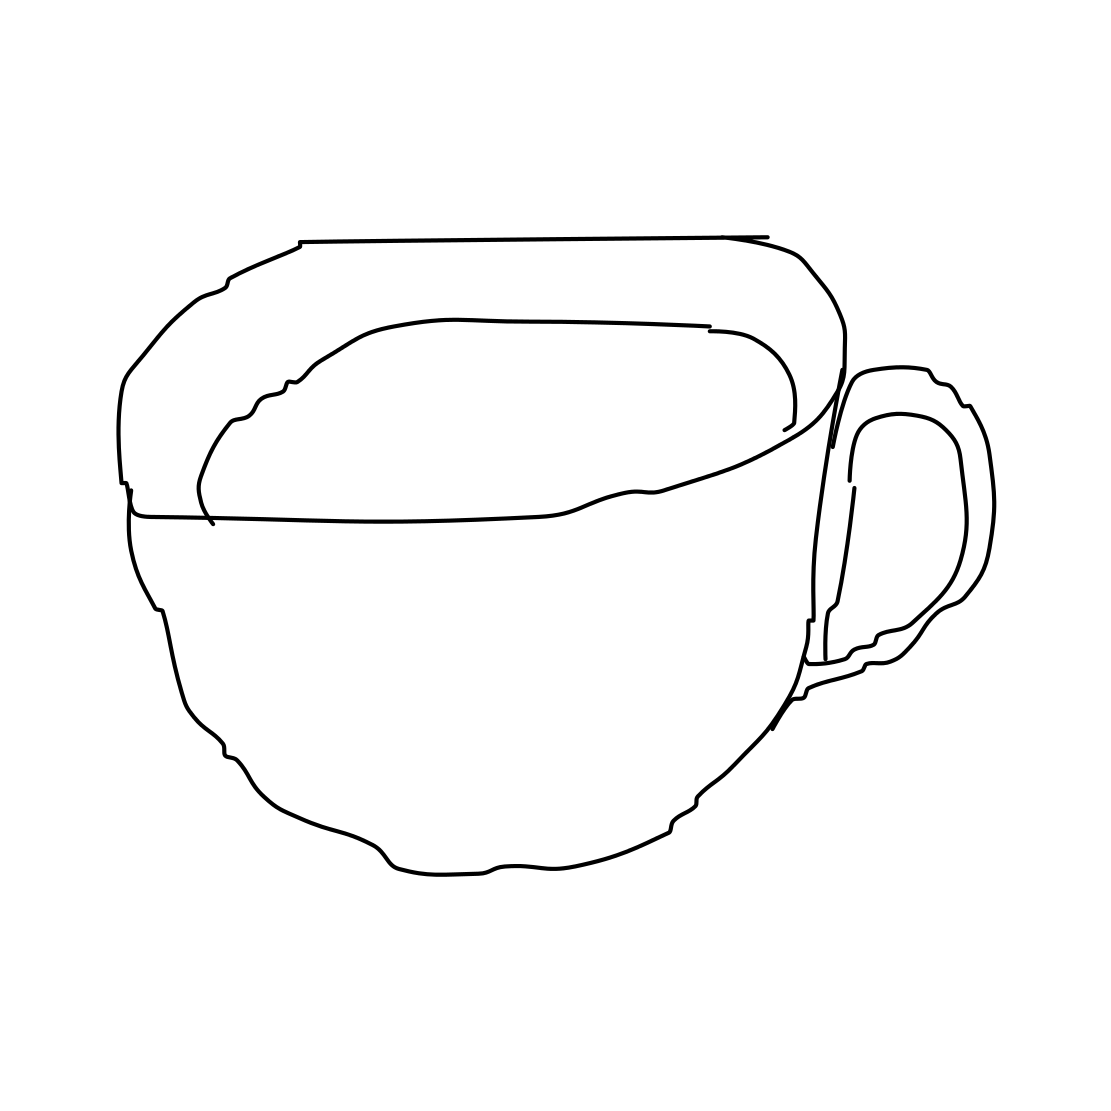Could this image be part of a larger set or collection? It's possible. The minimalist style suggests it could belong to a set that features similar line drawings of various kitchenware or household items, often used in matching sets or thematic designs. 